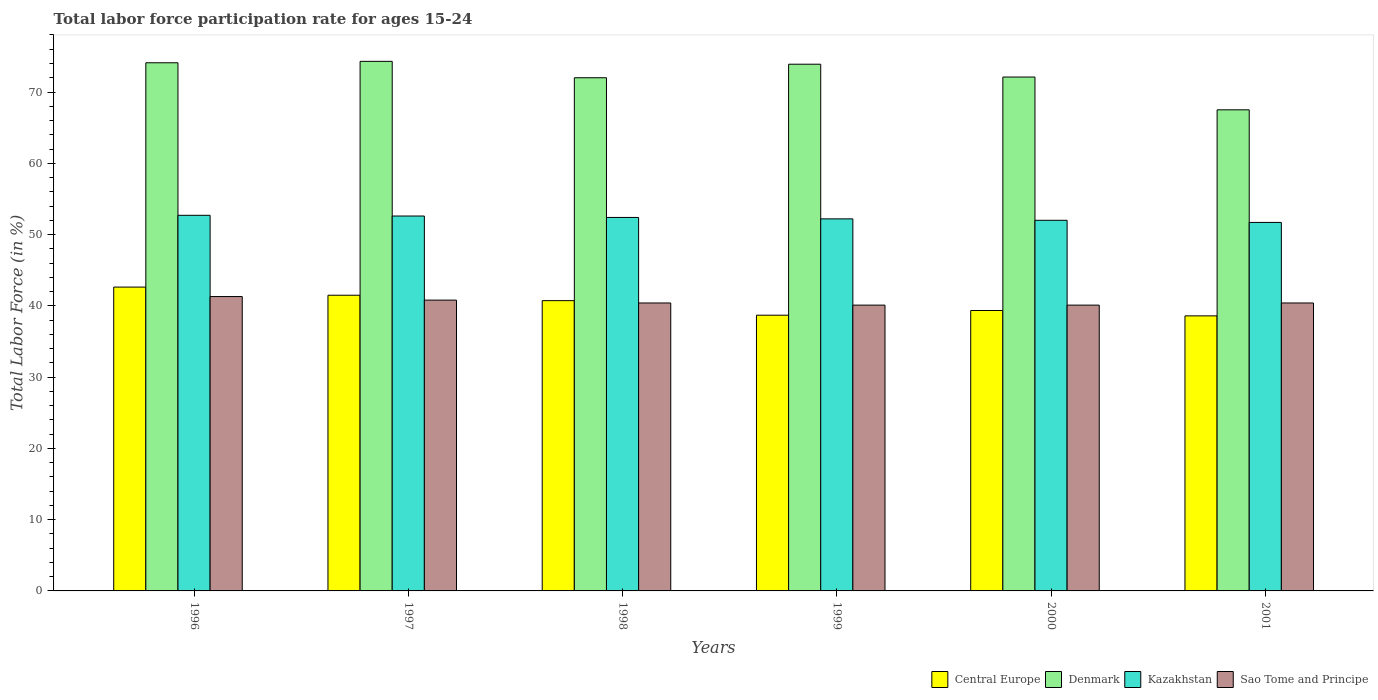How many groups of bars are there?
Keep it short and to the point. 6. Are the number of bars per tick equal to the number of legend labels?
Your answer should be very brief. Yes. Are the number of bars on each tick of the X-axis equal?
Offer a very short reply. Yes. How many bars are there on the 1st tick from the left?
Keep it short and to the point. 4. What is the labor force participation rate in Sao Tome and Principe in 1996?
Give a very brief answer. 41.3. Across all years, what is the maximum labor force participation rate in Denmark?
Offer a terse response. 74.3. Across all years, what is the minimum labor force participation rate in Sao Tome and Principe?
Your response must be concise. 40.1. In which year was the labor force participation rate in Kazakhstan minimum?
Keep it short and to the point. 2001. What is the total labor force participation rate in Denmark in the graph?
Make the answer very short. 433.9. What is the difference between the labor force participation rate in Kazakhstan in 1996 and that in 1998?
Ensure brevity in your answer.  0.3. What is the difference between the labor force participation rate in Sao Tome and Principe in 2000 and the labor force participation rate in Kazakhstan in 2001?
Make the answer very short. -11.6. What is the average labor force participation rate in Central Europe per year?
Offer a terse response. 40.24. In the year 1996, what is the difference between the labor force participation rate in Denmark and labor force participation rate in Sao Tome and Principe?
Keep it short and to the point. 32.8. In how many years, is the labor force participation rate in Kazakhstan greater than 34 %?
Offer a terse response. 6. What is the ratio of the labor force participation rate in Kazakhstan in 1998 to that in 1999?
Keep it short and to the point. 1. Is the labor force participation rate in Central Europe in 1997 less than that in 1999?
Keep it short and to the point. No. Is the difference between the labor force participation rate in Denmark in 1997 and 2001 greater than the difference between the labor force participation rate in Sao Tome and Principe in 1997 and 2001?
Provide a short and direct response. Yes. What is the difference between the highest and the second highest labor force participation rate in Central Europe?
Offer a terse response. 1.14. What is the difference between the highest and the lowest labor force participation rate in Denmark?
Offer a terse response. 6.8. Is the sum of the labor force participation rate in Sao Tome and Principe in 1999 and 2001 greater than the maximum labor force participation rate in Central Europe across all years?
Provide a short and direct response. Yes. Is it the case that in every year, the sum of the labor force participation rate in Sao Tome and Principe and labor force participation rate in Denmark is greater than the sum of labor force participation rate in Kazakhstan and labor force participation rate in Central Europe?
Your response must be concise. Yes. What does the 4th bar from the left in 2001 represents?
Ensure brevity in your answer.  Sao Tome and Principe. How many bars are there?
Your answer should be very brief. 24. Are all the bars in the graph horizontal?
Give a very brief answer. No. Are the values on the major ticks of Y-axis written in scientific E-notation?
Ensure brevity in your answer.  No. Does the graph contain grids?
Your answer should be very brief. No. Where does the legend appear in the graph?
Give a very brief answer. Bottom right. How many legend labels are there?
Provide a succinct answer. 4. How are the legend labels stacked?
Your response must be concise. Horizontal. What is the title of the graph?
Give a very brief answer. Total labor force participation rate for ages 15-24. Does "Lebanon" appear as one of the legend labels in the graph?
Ensure brevity in your answer.  No. What is the label or title of the X-axis?
Your response must be concise. Years. What is the Total Labor Force (in %) of Central Europe in 1996?
Offer a terse response. 42.63. What is the Total Labor Force (in %) of Denmark in 1996?
Provide a short and direct response. 74.1. What is the Total Labor Force (in %) of Kazakhstan in 1996?
Make the answer very short. 52.7. What is the Total Labor Force (in %) in Sao Tome and Principe in 1996?
Your answer should be compact. 41.3. What is the Total Labor Force (in %) of Central Europe in 1997?
Your response must be concise. 41.49. What is the Total Labor Force (in %) of Denmark in 1997?
Your response must be concise. 74.3. What is the Total Labor Force (in %) of Kazakhstan in 1997?
Your answer should be compact. 52.6. What is the Total Labor Force (in %) of Sao Tome and Principe in 1997?
Ensure brevity in your answer.  40.8. What is the Total Labor Force (in %) of Central Europe in 1998?
Provide a succinct answer. 40.73. What is the Total Labor Force (in %) of Denmark in 1998?
Your answer should be very brief. 72. What is the Total Labor Force (in %) in Kazakhstan in 1998?
Provide a short and direct response. 52.4. What is the Total Labor Force (in %) in Sao Tome and Principe in 1998?
Offer a terse response. 40.4. What is the Total Labor Force (in %) in Central Europe in 1999?
Provide a succinct answer. 38.69. What is the Total Labor Force (in %) of Denmark in 1999?
Give a very brief answer. 73.9. What is the Total Labor Force (in %) of Kazakhstan in 1999?
Offer a terse response. 52.2. What is the Total Labor Force (in %) in Sao Tome and Principe in 1999?
Your answer should be compact. 40.1. What is the Total Labor Force (in %) in Central Europe in 2000?
Keep it short and to the point. 39.34. What is the Total Labor Force (in %) of Denmark in 2000?
Offer a very short reply. 72.1. What is the Total Labor Force (in %) in Sao Tome and Principe in 2000?
Offer a terse response. 40.1. What is the Total Labor Force (in %) in Central Europe in 2001?
Your answer should be compact. 38.59. What is the Total Labor Force (in %) in Denmark in 2001?
Offer a terse response. 67.5. What is the Total Labor Force (in %) in Kazakhstan in 2001?
Offer a terse response. 51.7. What is the Total Labor Force (in %) of Sao Tome and Principe in 2001?
Make the answer very short. 40.4. Across all years, what is the maximum Total Labor Force (in %) of Central Europe?
Give a very brief answer. 42.63. Across all years, what is the maximum Total Labor Force (in %) of Denmark?
Your response must be concise. 74.3. Across all years, what is the maximum Total Labor Force (in %) of Kazakhstan?
Offer a very short reply. 52.7. Across all years, what is the maximum Total Labor Force (in %) of Sao Tome and Principe?
Your answer should be compact. 41.3. Across all years, what is the minimum Total Labor Force (in %) of Central Europe?
Keep it short and to the point. 38.59. Across all years, what is the minimum Total Labor Force (in %) in Denmark?
Your answer should be very brief. 67.5. Across all years, what is the minimum Total Labor Force (in %) in Kazakhstan?
Ensure brevity in your answer.  51.7. Across all years, what is the minimum Total Labor Force (in %) of Sao Tome and Principe?
Your response must be concise. 40.1. What is the total Total Labor Force (in %) of Central Europe in the graph?
Your answer should be compact. 241.46. What is the total Total Labor Force (in %) of Denmark in the graph?
Give a very brief answer. 433.9. What is the total Total Labor Force (in %) in Kazakhstan in the graph?
Provide a short and direct response. 313.6. What is the total Total Labor Force (in %) in Sao Tome and Principe in the graph?
Offer a terse response. 243.1. What is the difference between the Total Labor Force (in %) of Central Europe in 1996 and that in 1997?
Your answer should be very brief. 1.14. What is the difference between the Total Labor Force (in %) of Denmark in 1996 and that in 1997?
Your response must be concise. -0.2. What is the difference between the Total Labor Force (in %) in Kazakhstan in 1996 and that in 1997?
Offer a very short reply. 0.1. What is the difference between the Total Labor Force (in %) in Sao Tome and Principe in 1996 and that in 1997?
Provide a short and direct response. 0.5. What is the difference between the Total Labor Force (in %) in Central Europe in 1996 and that in 1998?
Your answer should be very brief. 1.9. What is the difference between the Total Labor Force (in %) of Sao Tome and Principe in 1996 and that in 1998?
Your answer should be very brief. 0.9. What is the difference between the Total Labor Force (in %) of Central Europe in 1996 and that in 1999?
Offer a terse response. 3.94. What is the difference between the Total Labor Force (in %) in Denmark in 1996 and that in 1999?
Provide a succinct answer. 0.2. What is the difference between the Total Labor Force (in %) of Kazakhstan in 1996 and that in 1999?
Offer a very short reply. 0.5. What is the difference between the Total Labor Force (in %) in Central Europe in 1996 and that in 2000?
Provide a succinct answer. 3.29. What is the difference between the Total Labor Force (in %) of Denmark in 1996 and that in 2000?
Keep it short and to the point. 2. What is the difference between the Total Labor Force (in %) in Central Europe in 1996 and that in 2001?
Keep it short and to the point. 4.04. What is the difference between the Total Labor Force (in %) in Central Europe in 1997 and that in 1998?
Offer a terse response. 0.76. What is the difference between the Total Labor Force (in %) in Denmark in 1997 and that in 1998?
Ensure brevity in your answer.  2.3. What is the difference between the Total Labor Force (in %) in Central Europe in 1997 and that in 1999?
Provide a short and direct response. 2.8. What is the difference between the Total Labor Force (in %) of Central Europe in 1997 and that in 2000?
Offer a terse response. 2.14. What is the difference between the Total Labor Force (in %) of Denmark in 1997 and that in 2000?
Make the answer very short. 2.2. What is the difference between the Total Labor Force (in %) in Kazakhstan in 1997 and that in 2000?
Your answer should be very brief. 0.6. What is the difference between the Total Labor Force (in %) in Sao Tome and Principe in 1997 and that in 2000?
Give a very brief answer. 0.7. What is the difference between the Total Labor Force (in %) in Central Europe in 1997 and that in 2001?
Offer a terse response. 2.9. What is the difference between the Total Labor Force (in %) of Denmark in 1997 and that in 2001?
Make the answer very short. 6.8. What is the difference between the Total Labor Force (in %) in Central Europe in 1998 and that in 1999?
Keep it short and to the point. 2.04. What is the difference between the Total Labor Force (in %) in Kazakhstan in 1998 and that in 1999?
Ensure brevity in your answer.  0.2. What is the difference between the Total Labor Force (in %) in Sao Tome and Principe in 1998 and that in 1999?
Offer a very short reply. 0.3. What is the difference between the Total Labor Force (in %) in Central Europe in 1998 and that in 2000?
Offer a terse response. 1.39. What is the difference between the Total Labor Force (in %) of Denmark in 1998 and that in 2000?
Your answer should be compact. -0.1. What is the difference between the Total Labor Force (in %) of Kazakhstan in 1998 and that in 2000?
Keep it short and to the point. 0.4. What is the difference between the Total Labor Force (in %) in Central Europe in 1998 and that in 2001?
Offer a very short reply. 2.14. What is the difference between the Total Labor Force (in %) in Kazakhstan in 1998 and that in 2001?
Provide a succinct answer. 0.7. What is the difference between the Total Labor Force (in %) in Sao Tome and Principe in 1998 and that in 2001?
Ensure brevity in your answer.  0. What is the difference between the Total Labor Force (in %) of Central Europe in 1999 and that in 2000?
Provide a succinct answer. -0.66. What is the difference between the Total Labor Force (in %) of Denmark in 1999 and that in 2000?
Your response must be concise. 1.8. What is the difference between the Total Labor Force (in %) of Sao Tome and Principe in 1999 and that in 2000?
Provide a succinct answer. 0. What is the difference between the Total Labor Force (in %) of Central Europe in 1999 and that in 2001?
Give a very brief answer. 0.09. What is the difference between the Total Labor Force (in %) in Denmark in 1999 and that in 2001?
Provide a succinct answer. 6.4. What is the difference between the Total Labor Force (in %) of Central Europe in 2000 and that in 2001?
Give a very brief answer. 0.75. What is the difference between the Total Labor Force (in %) of Kazakhstan in 2000 and that in 2001?
Keep it short and to the point. 0.3. What is the difference between the Total Labor Force (in %) in Central Europe in 1996 and the Total Labor Force (in %) in Denmark in 1997?
Give a very brief answer. -31.67. What is the difference between the Total Labor Force (in %) in Central Europe in 1996 and the Total Labor Force (in %) in Kazakhstan in 1997?
Give a very brief answer. -9.97. What is the difference between the Total Labor Force (in %) of Central Europe in 1996 and the Total Labor Force (in %) of Sao Tome and Principe in 1997?
Your answer should be compact. 1.83. What is the difference between the Total Labor Force (in %) of Denmark in 1996 and the Total Labor Force (in %) of Kazakhstan in 1997?
Provide a succinct answer. 21.5. What is the difference between the Total Labor Force (in %) of Denmark in 1996 and the Total Labor Force (in %) of Sao Tome and Principe in 1997?
Provide a succinct answer. 33.3. What is the difference between the Total Labor Force (in %) of Central Europe in 1996 and the Total Labor Force (in %) of Denmark in 1998?
Your response must be concise. -29.37. What is the difference between the Total Labor Force (in %) of Central Europe in 1996 and the Total Labor Force (in %) of Kazakhstan in 1998?
Offer a terse response. -9.77. What is the difference between the Total Labor Force (in %) in Central Europe in 1996 and the Total Labor Force (in %) in Sao Tome and Principe in 1998?
Your answer should be very brief. 2.23. What is the difference between the Total Labor Force (in %) of Denmark in 1996 and the Total Labor Force (in %) of Kazakhstan in 1998?
Offer a terse response. 21.7. What is the difference between the Total Labor Force (in %) of Denmark in 1996 and the Total Labor Force (in %) of Sao Tome and Principe in 1998?
Offer a very short reply. 33.7. What is the difference between the Total Labor Force (in %) in Central Europe in 1996 and the Total Labor Force (in %) in Denmark in 1999?
Your response must be concise. -31.27. What is the difference between the Total Labor Force (in %) of Central Europe in 1996 and the Total Labor Force (in %) of Kazakhstan in 1999?
Give a very brief answer. -9.57. What is the difference between the Total Labor Force (in %) of Central Europe in 1996 and the Total Labor Force (in %) of Sao Tome and Principe in 1999?
Your answer should be compact. 2.53. What is the difference between the Total Labor Force (in %) of Denmark in 1996 and the Total Labor Force (in %) of Kazakhstan in 1999?
Ensure brevity in your answer.  21.9. What is the difference between the Total Labor Force (in %) in Denmark in 1996 and the Total Labor Force (in %) in Sao Tome and Principe in 1999?
Ensure brevity in your answer.  34. What is the difference between the Total Labor Force (in %) of Central Europe in 1996 and the Total Labor Force (in %) of Denmark in 2000?
Give a very brief answer. -29.47. What is the difference between the Total Labor Force (in %) of Central Europe in 1996 and the Total Labor Force (in %) of Kazakhstan in 2000?
Make the answer very short. -9.37. What is the difference between the Total Labor Force (in %) in Central Europe in 1996 and the Total Labor Force (in %) in Sao Tome and Principe in 2000?
Offer a very short reply. 2.53. What is the difference between the Total Labor Force (in %) in Denmark in 1996 and the Total Labor Force (in %) in Kazakhstan in 2000?
Offer a very short reply. 22.1. What is the difference between the Total Labor Force (in %) in Denmark in 1996 and the Total Labor Force (in %) in Sao Tome and Principe in 2000?
Offer a terse response. 34. What is the difference between the Total Labor Force (in %) in Central Europe in 1996 and the Total Labor Force (in %) in Denmark in 2001?
Offer a very short reply. -24.87. What is the difference between the Total Labor Force (in %) in Central Europe in 1996 and the Total Labor Force (in %) in Kazakhstan in 2001?
Make the answer very short. -9.07. What is the difference between the Total Labor Force (in %) of Central Europe in 1996 and the Total Labor Force (in %) of Sao Tome and Principe in 2001?
Provide a short and direct response. 2.23. What is the difference between the Total Labor Force (in %) in Denmark in 1996 and the Total Labor Force (in %) in Kazakhstan in 2001?
Your answer should be very brief. 22.4. What is the difference between the Total Labor Force (in %) of Denmark in 1996 and the Total Labor Force (in %) of Sao Tome and Principe in 2001?
Give a very brief answer. 33.7. What is the difference between the Total Labor Force (in %) of Central Europe in 1997 and the Total Labor Force (in %) of Denmark in 1998?
Your response must be concise. -30.51. What is the difference between the Total Labor Force (in %) in Central Europe in 1997 and the Total Labor Force (in %) in Kazakhstan in 1998?
Keep it short and to the point. -10.91. What is the difference between the Total Labor Force (in %) in Central Europe in 1997 and the Total Labor Force (in %) in Sao Tome and Principe in 1998?
Make the answer very short. 1.09. What is the difference between the Total Labor Force (in %) in Denmark in 1997 and the Total Labor Force (in %) in Kazakhstan in 1998?
Your answer should be compact. 21.9. What is the difference between the Total Labor Force (in %) in Denmark in 1997 and the Total Labor Force (in %) in Sao Tome and Principe in 1998?
Provide a succinct answer. 33.9. What is the difference between the Total Labor Force (in %) of Kazakhstan in 1997 and the Total Labor Force (in %) of Sao Tome and Principe in 1998?
Offer a terse response. 12.2. What is the difference between the Total Labor Force (in %) in Central Europe in 1997 and the Total Labor Force (in %) in Denmark in 1999?
Your answer should be very brief. -32.41. What is the difference between the Total Labor Force (in %) in Central Europe in 1997 and the Total Labor Force (in %) in Kazakhstan in 1999?
Make the answer very short. -10.71. What is the difference between the Total Labor Force (in %) in Central Europe in 1997 and the Total Labor Force (in %) in Sao Tome and Principe in 1999?
Your response must be concise. 1.39. What is the difference between the Total Labor Force (in %) of Denmark in 1997 and the Total Labor Force (in %) of Kazakhstan in 1999?
Keep it short and to the point. 22.1. What is the difference between the Total Labor Force (in %) of Denmark in 1997 and the Total Labor Force (in %) of Sao Tome and Principe in 1999?
Your answer should be very brief. 34.2. What is the difference between the Total Labor Force (in %) of Kazakhstan in 1997 and the Total Labor Force (in %) of Sao Tome and Principe in 1999?
Give a very brief answer. 12.5. What is the difference between the Total Labor Force (in %) in Central Europe in 1997 and the Total Labor Force (in %) in Denmark in 2000?
Keep it short and to the point. -30.61. What is the difference between the Total Labor Force (in %) in Central Europe in 1997 and the Total Labor Force (in %) in Kazakhstan in 2000?
Keep it short and to the point. -10.51. What is the difference between the Total Labor Force (in %) of Central Europe in 1997 and the Total Labor Force (in %) of Sao Tome and Principe in 2000?
Your response must be concise. 1.39. What is the difference between the Total Labor Force (in %) of Denmark in 1997 and the Total Labor Force (in %) of Kazakhstan in 2000?
Your answer should be very brief. 22.3. What is the difference between the Total Labor Force (in %) in Denmark in 1997 and the Total Labor Force (in %) in Sao Tome and Principe in 2000?
Ensure brevity in your answer.  34.2. What is the difference between the Total Labor Force (in %) in Central Europe in 1997 and the Total Labor Force (in %) in Denmark in 2001?
Provide a succinct answer. -26.01. What is the difference between the Total Labor Force (in %) in Central Europe in 1997 and the Total Labor Force (in %) in Kazakhstan in 2001?
Your response must be concise. -10.21. What is the difference between the Total Labor Force (in %) of Central Europe in 1997 and the Total Labor Force (in %) of Sao Tome and Principe in 2001?
Ensure brevity in your answer.  1.09. What is the difference between the Total Labor Force (in %) of Denmark in 1997 and the Total Labor Force (in %) of Kazakhstan in 2001?
Give a very brief answer. 22.6. What is the difference between the Total Labor Force (in %) of Denmark in 1997 and the Total Labor Force (in %) of Sao Tome and Principe in 2001?
Ensure brevity in your answer.  33.9. What is the difference between the Total Labor Force (in %) of Kazakhstan in 1997 and the Total Labor Force (in %) of Sao Tome and Principe in 2001?
Your answer should be compact. 12.2. What is the difference between the Total Labor Force (in %) in Central Europe in 1998 and the Total Labor Force (in %) in Denmark in 1999?
Provide a short and direct response. -33.17. What is the difference between the Total Labor Force (in %) of Central Europe in 1998 and the Total Labor Force (in %) of Kazakhstan in 1999?
Offer a very short reply. -11.47. What is the difference between the Total Labor Force (in %) in Central Europe in 1998 and the Total Labor Force (in %) in Sao Tome and Principe in 1999?
Provide a short and direct response. 0.63. What is the difference between the Total Labor Force (in %) of Denmark in 1998 and the Total Labor Force (in %) of Kazakhstan in 1999?
Offer a very short reply. 19.8. What is the difference between the Total Labor Force (in %) of Denmark in 1998 and the Total Labor Force (in %) of Sao Tome and Principe in 1999?
Give a very brief answer. 31.9. What is the difference between the Total Labor Force (in %) of Central Europe in 1998 and the Total Labor Force (in %) of Denmark in 2000?
Ensure brevity in your answer.  -31.37. What is the difference between the Total Labor Force (in %) in Central Europe in 1998 and the Total Labor Force (in %) in Kazakhstan in 2000?
Ensure brevity in your answer.  -11.27. What is the difference between the Total Labor Force (in %) in Central Europe in 1998 and the Total Labor Force (in %) in Sao Tome and Principe in 2000?
Provide a short and direct response. 0.63. What is the difference between the Total Labor Force (in %) of Denmark in 1998 and the Total Labor Force (in %) of Sao Tome and Principe in 2000?
Your response must be concise. 31.9. What is the difference between the Total Labor Force (in %) of Central Europe in 1998 and the Total Labor Force (in %) of Denmark in 2001?
Offer a terse response. -26.77. What is the difference between the Total Labor Force (in %) in Central Europe in 1998 and the Total Labor Force (in %) in Kazakhstan in 2001?
Offer a terse response. -10.97. What is the difference between the Total Labor Force (in %) in Central Europe in 1998 and the Total Labor Force (in %) in Sao Tome and Principe in 2001?
Your answer should be compact. 0.33. What is the difference between the Total Labor Force (in %) of Denmark in 1998 and the Total Labor Force (in %) of Kazakhstan in 2001?
Offer a very short reply. 20.3. What is the difference between the Total Labor Force (in %) of Denmark in 1998 and the Total Labor Force (in %) of Sao Tome and Principe in 2001?
Provide a short and direct response. 31.6. What is the difference between the Total Labor Force (in %) in Central Europe in 1999 and the Total Labor Force (in %) in Denmark in 2000?
Offer a terse response. -33.41. What is the difference between the Total Labor Force (in %) of Central Europe in 1999 and the Total Labor Force (in %) of Kazakhstan in 2000?
Ensure brevity in your answer.  -13.31. What is the difference between the Total Labor Force (in %) in Central Europe in 1999 and the Total Labor Force (in %) in Sao Tome and Principe in 2000?
Ensure brevity in your answer.  -1.41. What is the difference between the Total Labor Force (in %) in Denmark in 1999 and the Total Labor Force (in %) in Kazakhstan in 2000?
Your response must be concise. 21.9. What is the difference between the Total Labor Force (in %) in Denmark in 1999 and the Total Labor Force (in %) in Sao Tome and Principe in 2000?
Your answer should be compact. 33.8. What is the difference between the Total Labor Force (in %) in Central Europe in 1999 and the Total Labor Force (in %) in Denmark in 2001?
Offer a very short reply. -28.81. What is the difference between the Total Labor Force (in %) in Central Europe in 1999 and the Total Labor Force (in %) in Kazakhstan in 2001?
Give a very brief answer. -13.01. What is the difference between the Total Labor Force (in %) of Central Europe in 1999 and the Total Labor Force (in %) of Sao Tome and Principe in 2001?
Ensure brevity in your answer.  -1.71. What is the difference between the Total Labor Force (in %) in Denmark in 1999 and the Total Labor Force (in %) in Sao Tome and Principe in 2001?
Provide a short and direct response. 33.5. What is the difference between the Total Labor Force (in %) of Kazakhstan in 1999 and the Total Labor Force (in %) of Sao Tome and Principe in 2001?
Ensure brevity in your answer.  11.8. What is the difference between the Total Labor Force (in %) in Central Europe in 2000 and the Total Labor Force (in %) in Denmark in 2001?
Ensure brevity in your answer.  -28.16. What is the difference between the Total Labor Force (in %) in Central Europe in 2000 and the Total Labor Force (in %) in Kazakhstan in 2001?
Offer a very short reply. -12.36. What is the difference between the Total Labor Force (in %) in Central Europe in 2000 and the Total Labor Force (in %) in Sao Tome and Principe in 2001?
Offer a very short reply. -1.06. What is the difference between the Total Labor Force (in %) of Denmark in 2000 and the Total Labor Force (in %) of Kazakhstan in 2001?
Keep it short and to the point. 20.4. What is the difference between the Total Labor Force (in %) in Denmark in 2000 and the Total Labor Force (in %) in Sao Tome and Principe in 2001?
Offer a very short reply. 31.7. What is the difference between the Total Labor Force (in %) of Kazakhstan in 2000 and the Total Labor Force (in %) of Sao Tome and Principe in 2001?
Your answer should be compact. 11.6. What is the average Total Labor Force (in %) of Central Europe per year?
Give a very brief answer. 40.24. What is the average Total Labor Force (in %) in Denmark per year?
Offer a terse response. 72.32. What is the average Total Labor Force (in %) in Kazakhstan per year?
Offer a terse response. 52.27. What is the average Total Labor Force (in %) of Sao Tome and Principe per year?
Your answer should be very brief. 40.52. In the year 1996, what is the difference between the Total Labor Force (in %) in Central Europe and Total Labor Force (in %) in Denmark?
Ensure brevity in your answer.  -31.47. In the year 1996, what is the difference between the Total Labor Force (in %) of Central Europe and Total Labor Force (in %) of Kazakhstan?
Provide a short and direct response. -10.07. In the year 1996, what is the difference between the Total Labor Force (in %) in Central Europe and Total Labor Force (in %) in Sao Tome and Principe?
Give a very brief answer. 1.33. In the year 1996, what is the difference between the Total Labor Force (in %) of Denmark and Total Labor Force (in %) of Kazakhstan?
Your answer should be very brief. 21.4. In the year 1996, what is the difference between the Total Labor Force (in %) of Denmark and Total Labor Force (in %) of Sao Tome and Principe?
Offer a terse response. 32.8. In the year 1997, what is the difference between the Total Labor Force (in %) in Central Europe and Total Labor Force (in %) in Denmark?
Ensure brevity in your answer.  -32.81. In the year 1997, what is the difference between the Total Labor Force (in %) in Central Europe and Total Labor Force (in %) in Kazakhstan?
Offer a terse response. -11.11. In the year 1997, what is the difference between the Total Labor Force (in %) in Central Europe and Total Labor Force (in %) in Sao Tome and Principe?
Your response must be concise. 0.69. In the year 1997, what is the difference between the Total Labor Force (in %) in Denmark and Total Labor Force (in %) in Kazakhstan?
Keep it short and to the point. 21.7. In the year 1997, what is the difference between the Total Labor Force (in %) in Denmark and Total Labor Force (in %) in Sao Tome and Principe?
Keep it short and to the point. 33.5. In the year 1998, what is the difference between the Total Labor Force (in %) of Central Europe and Total Labor Force (in %) of Denmark?
Ensure brevity in your answer.  -31.27. In the year 1998, what is the difference between the Total Labor Force (in %) of Central Europe and Total Labor Force (in %) of Kazakhstan?
Your response must be concise. -11.67. In the year 1998, what is the difference between the Total Labor Force (in %) in Central Europe and Total Labor Force (in %) in Sao Tome and Principe?
Ensure brevity in your answer.  0.33. In the year 1998, what is the difference between the Total Labor Force (in %) of Denmark and Total Labor Force (in %) of Kazakhstan?
Offer a terse response. 19.6. In the year 1998, what is the difference between the Total Labor Force (in %) in Denmark and Total Labor Force (in %) in Sao Tome and Principe?
Your answer should be very brief. 31.6. In the year 1999, what is the difference between the Total Labor Force (in %) in Central Europe and Total Labor Force (in %) in Denmark?
Offer a terse response. -35.21. In the year 1999, what is the difference between the Total Labor Force (in %) in Central Europe and Total Labor Force (in %) in Kazakhstan?
Make the answer very short. -13.51. In the year 1999, what is the difference between the Total Labor Force (in %) in Central Europe and Total Labor Force (in %) in Sao Tome and Principe?
Give a very brief answer. -1.41. In the year 1999, what is the difference between the Total Labor Force (in %) in Denmark and Total Labor Force (in %) in Kazakhstan?
Your answer should be compact. 21.7. In the year 1999, what is the difference between the Total Labor Force (in %) in Denmark and Total Labor Force (in %) in Sao Tome and Principe?
Give a very brief answer. 33.8. In the year 1999, what is the difference between the Total Labor Force (in %) in Kazakhstan and Total Labor Force (in %) in Sao Tome and Principe?
Your response must be concise. 12.1. In the year 2000, what is the difference between the Total Labor Force (in %) of Central Europe and Total Labor Force (in %) of Denmark?
Your answer should be compact. -32.76. In the year 2000, what is the difference between the Total Labor Force (in %) of Central Europe and Total Labor Force (in %) of Kazakhstan?
Keep it short and to the point. -12.66. In the year 2000, what is the difference between the Total Labor Force (in %) of Central Europe and Total Labor Force (in %) of Sao Tome and Principe?
Your answer should be very brief. -0.76. In the year 2000, what is the difference between the Total Labor Force (in %) of Denmark and Total Labor Force (in %) of Kazakhstan?
Offer a terse response. 20.1. In the year 2001, what is the difference between the Total Labor Force (in %) of Central Europe and Total Labor Force (in %) of Denmark?
Ensure brevity in your answer.  -28.91. In the year 2001, what is the difference between the Total Labor Force (in %) in Central Europe and Total Labor Force (in %) in Kazakhstan?
Offer a terse response. -13.11. In the year 2001, what is the difference between the Total Labor Force (in %) in Central Europe and Total Labor Force (in %) in Sao Tome and Principe?
Offer a terse response. -1.81. In the year 2001, what is the difference between the Total Labor Force (in %) in Denmark and Total Labor Force (in %) in Kazakhstan?
Provide a short and direct response. 15.8. In the year 2001, what is the difference between the Total Labor Force (in %) of Denmark and Total Labor Force (in %) of Sao Tome and Principe?
Make the answer very short. 27.1. In the year 2001, what is the difference between the Total Labor Force (in %) in Kazakhstan and Total Labor Force (in %) in Sao Tome and Principe?
Your response must be concise. 11.3. What is the ratio of the Total Labor Force (in %) in Central Europe in 1996 to that in 1997?
Give a very brief answer. 1.03. What is the ratio of the Total Labor Force (in %) in Kazakhstan in 1996 to that in 1997?
Your response must be concise. 1. What is the ratio of the Total Labor Force (in %) of Sao Tome and Principe in 1996 to that in 1997?
Ensure brevity in your answer.  1.01. What is the ratio of the Total Labor Force (in %) in Central Europe in 1996 to that in 1998?
Give a very brief answer. 1.05. What is the ratio of the Total Labor Force (in %) in Denmark in 1996 to that in 1998?
Your answer should be compact. 1.03. What is the ratio of the Total Labor Force (in %) of Sao Tome and Principe in 1996 to that in 1998?
Offer a terse response. 1.02. What is the ratio of the Total Labor Force (in %) in Central Europe in 1996 to that in 1999?
Provide a short and direct response. 1.1. What is the ratio of the Total Labor Force (in %) in Kazakhstan in 1996 to that in 1999?
Offer a very short reply. 1.01. What is the ratio of the Total Labor Force (in %) in Sao Tome and Principe in 1996 to that in 1999?
Offer a terse response. 1.03. What is the ratio of the Total Labor Force (in %) of Central Europe in 1996 to that in 2000?
Keep it short and to the point. 1.08. What is the ratio of the Total Labor Force (in %) in Denmark in 1996 to that in 2000?
Provide a succinct answer. 1.03. What is the ratio of the Total Labor Force (in %) in Kazakhstan in 1996 to that in 2000?
Your answer should be compact. 1.01. What is the ratio of the Total Labor Force (in %) of Sao Tome and Principe in 1996 to that in 2000?
Make the answer very short. 1.03. What is the ratio of the Total Labor Force (in %) of Central Europe in 1996 to that in 2001?
Provide a short and direct response. 1.1. What is the ratio of the Total Labor Force (in %) in Denmark in 1996 to that in 2001?
Ensure brevity in your answer.  1.1. What is the ratio of the Total Labor Force (in %) in Kazakhstan in 1996 to that in 2001?
Provide a succinct answer. 1.02. What is the ratio of the Total Labor Force (in %) of Sao Tome and Principe in 1996 to that in 2001?
Keep it short and to the point. 1.02. What is the ratio of the Total Labor Force (in %) in Central Europe in 1997 to that in 1998?
Keep it short and to the point. 1.02. What is the ratio of the Total Labor Force (in %) of Denmark in 1997 to that in 1998?
Provide a short and direct response. 1.03. What is the ratio of the Total Labor Force (in %) of Sao Tome and Principe in 1997 to that in 1998?
Keep it short and to the point. 1.01. What is the ratio of the Total Labor Force (in %) in Central Europe in 1997 to that in 1999?
Offer a terse response. 1.07. What is the ratio of the Total Labor Force (in %) of Denmark in 1997 to that in 1999?
Ensure brevity in your answer.  1.01. What is the ratio of the Total Labor Force (in %) of Kazakhstan in 1997 to that in 1999?
Ensure brevity in your answer.  1.01. What is the ratio of the Total Labor Force (in %) in Sao Tome and Principe in 1997 to that in 1999?
Your response must be concise. 1.02. What is the ratio of the Total Labor Force (in %) in Central Europe in 1997 to that in 2000?
Offer a very short reply. 1.05. What is the ratio of the Total Labor Force (in %) of Denmark in 1997 to that in 2000?
Provide a succinct answer. 1.03. What is the ratio of the Total Labor Force (in %) in Kazakhstan in 1997 to that in 2000?
Keep it short and to the point. 1.01. What is the ratio of the Total Labor Force (in %) in Sao Tome and Principe in 1997 to that in 2000?
Provide a short and direct response. 1.02. What is the ratio of the Total Labor Force (in %) of Central Europe in 1997 to that in 2001?
Keep it short and to the point. 1.07. What is the ratio of the Total Labor Force (in %) of Denmark in 1997 to that in 2001?
Give a very brief answer. 1.1. What is the ratio of the Total Labor Force (in %) in Kazakhstan in 1997 to that in 2001?
Your answer should be very brief. 1.02. What is the ratio of the Total Labor Force (in %) of Sao Tome and Principe in 1997 to that in 2001?
Ensure brevity in your answer.  1.01. What is the ratio of the Total Labor Force (in %) of Central Europe in 1998 to that in 1999?
Your answer should be very brief. 1.05. What is the ratio of the Total Labor Force (in %) in Denmark in 1998 to that in 1999?
Make the answer very short. 0.97. What is the ratio of the Total Labor Force (in %) of Kazakhstan in 1998 to that in 1999?
Keep it short and to the point. 1. What is the ratio of the Total Labor Force (in %) in Sao Tome and Principe in 1998 to that in 1999?
Ensure brevity in your answer.  1.01. What is the ratio of the Total Labor Force (in %) in Central Europe in 1998 to that in 2000?
Your response must be concise. 1.04. What is the ratio of the Total Labor Force (in %) of Kazakhstan in 1998 to that in 2000?
Give a very brief answer. 1.01. What is the ratio of the Total Labor Force (in %) in Sao Tome and Principe in 1998 to that in 2000?
Make the answer very short. 1.01. What is the ratio of the Total Labor Force (in %) in Central Europe in 1998 to that in 2001?
Offer a terse response. 1.06. What is the ratio of the Total Labor Force (in %) of Denmark in 1998 to that in 2001?
Offer a very short reply. 1.07. What is the ratio of the Total Labor Force (in %) of Kazakhstan in 1998 to that in 2001?
Give a very brief answer. 1.01. What is the ratio of the Total Labor Force (in %) of Central Europe in 1999 to that in 2000?
Keep it short and to the point. 0.98. What is the ratio of the Total Labor Force (in %) of Denmark in 1999 to that in 2000?
Your answer should be compact. 1.02. What is the ratio of the Total Labor Force (in %) in Kazakhstan in 1999 to that in 2000?
Provide a succinct answer. 1. What is the ratio of the Total Labor Force (in %) of Sao Tome and Principe in 1999 to that in 2000?
Ensure brevity in your answer.  1. What is the ratio of the Total Labor Force (in %) in Denmark in 1999 to that in 2001?
Offer a terse response. 1.09. What is the ratio of the Total Labor Force (in %) in Kazakhstan in 1999 to that in 2001?
Provide a short and direct response. 1.01. What is the ratio of the Total Labor Force (in %) of Sao Tome and Principe in 1999 to that in 2001?
Give a very brief answer. 0.99. What is the ratio of the Total Labor Force (in %) of Central Europe in 2000 to that in 2001?
Give a very brief answer. 1.02. What is the ratio of the Total Labor Force (in %) in Denmark in 2000 to that in 2001?
Your answer should be compact. 1.07. What is the difference between the highest and the second highest Total Labor Force (in %) of Central Europe?
Your answer should be very brief. 1.14. What is the difference between the highest and the second highest Total Labor Force (in %) in Denmark?
Your answer should be compact. 0.2. What is the difference between the highest and the second highest Total Labor Force (in %) of Sao Tome and Principe?
Make the answer very short. 0.5. What is the difference between the highest and the lowest Total Labor Force (in %) in Central Europe?
Your answer should be very brief. 4.04. What is the difference between the highest and the lowest Total Labor Force (in %) of Sao Tome and Principe?
Give a very brief answer. 1.2. 